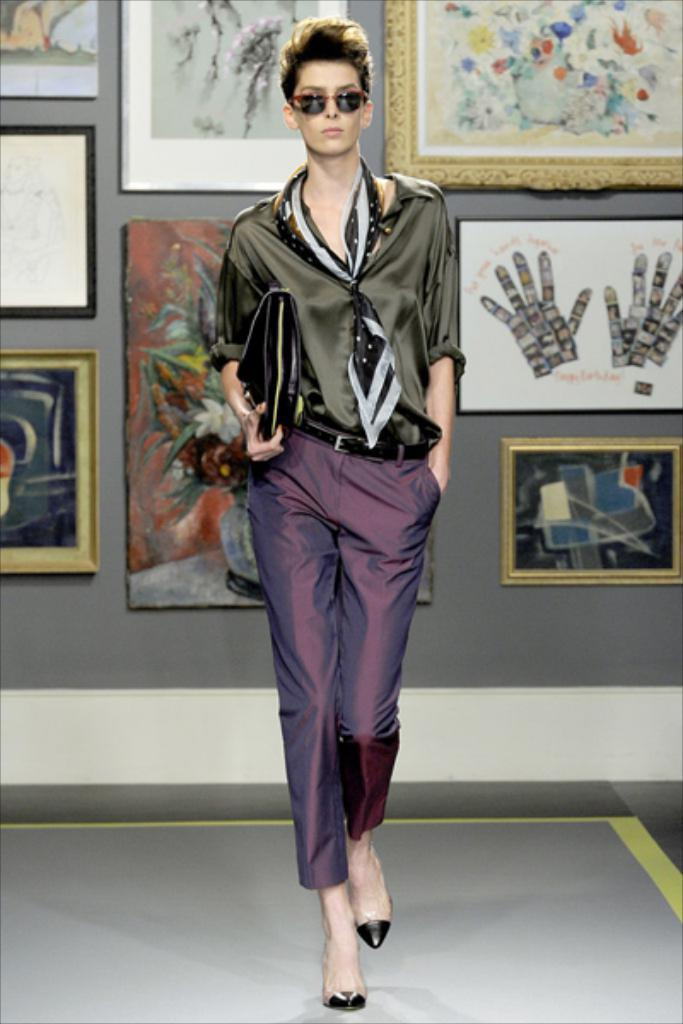Who is present in the image? There is a woman in the image. What is the woman doing in the image? The woman is standing on the floor. What is the woman holding in the image? The woman is holding an object. What can be seen in the background of the image? There are photo frames on a wall in the background of the image. Is the room in the image completely quiet? The provided facts do not mention the noise level in the room, so it cannot be determined from the image. 